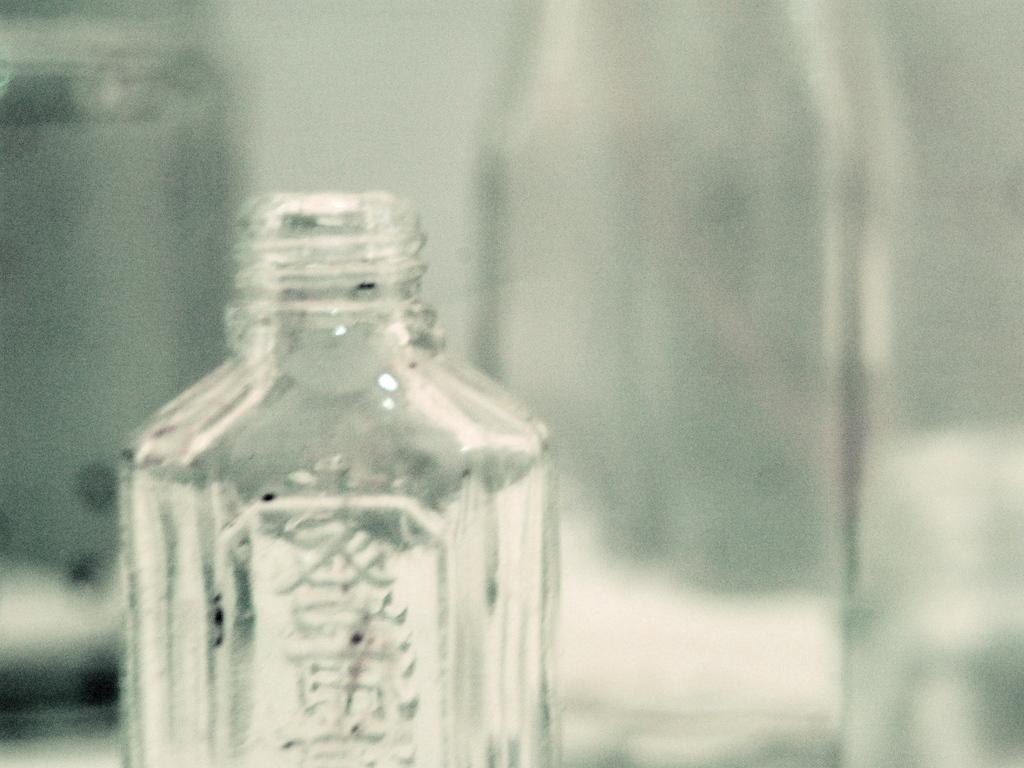Could you give a brief overview of what you see in this image? The picture contain some glass bottles. In the center of the picture there is a bottle. On the left there is a glass jar. And in the background there is another glass bottle. 